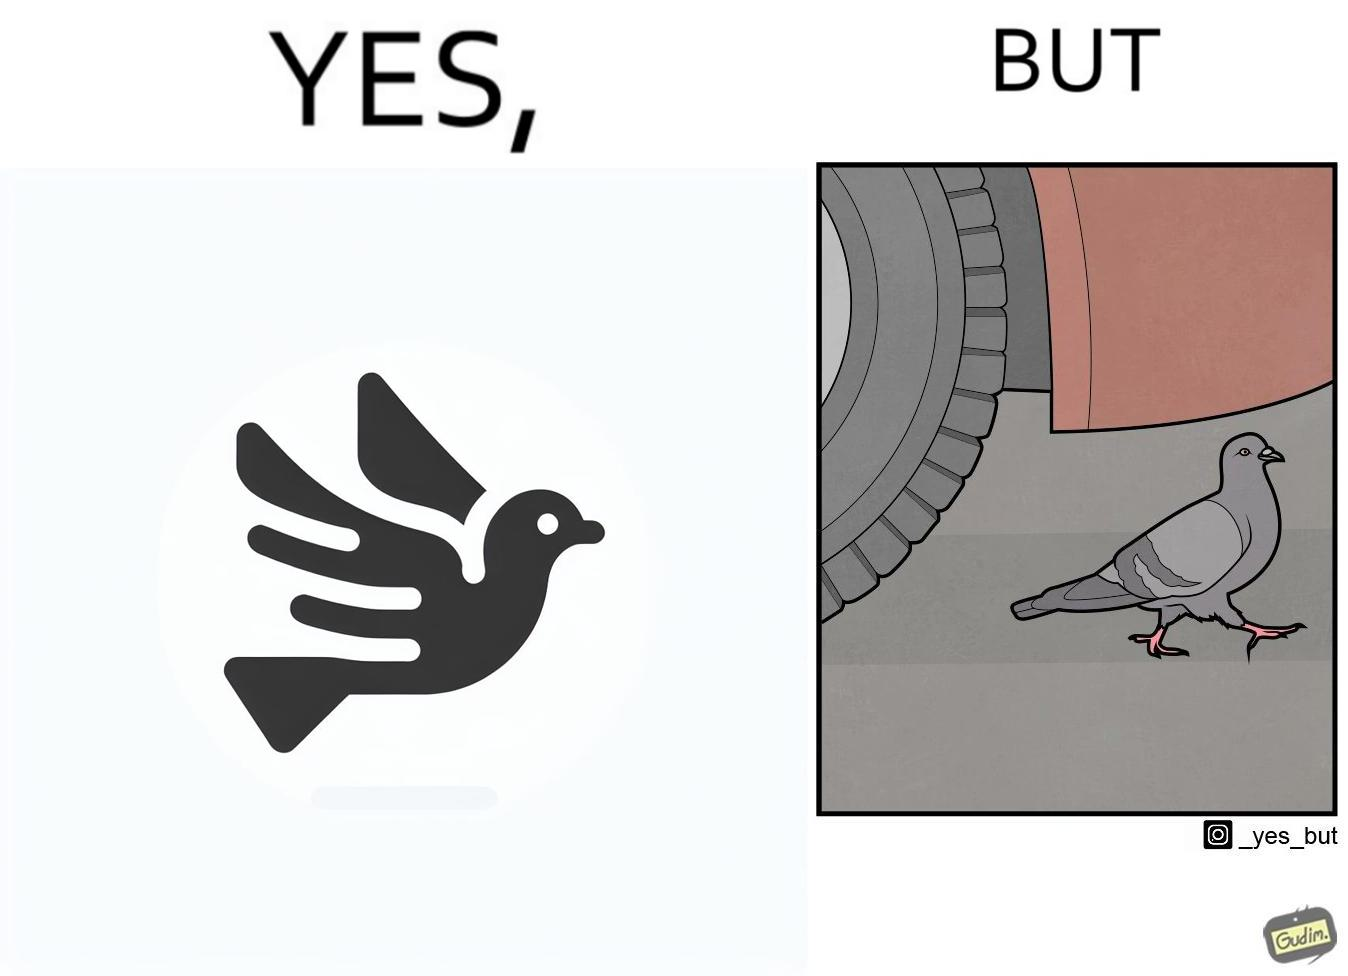What do you see in each half of this image? In the left part of the image: a grey pigeon flying in the sky In the right part of the image: a grey pigeon walking under a car 